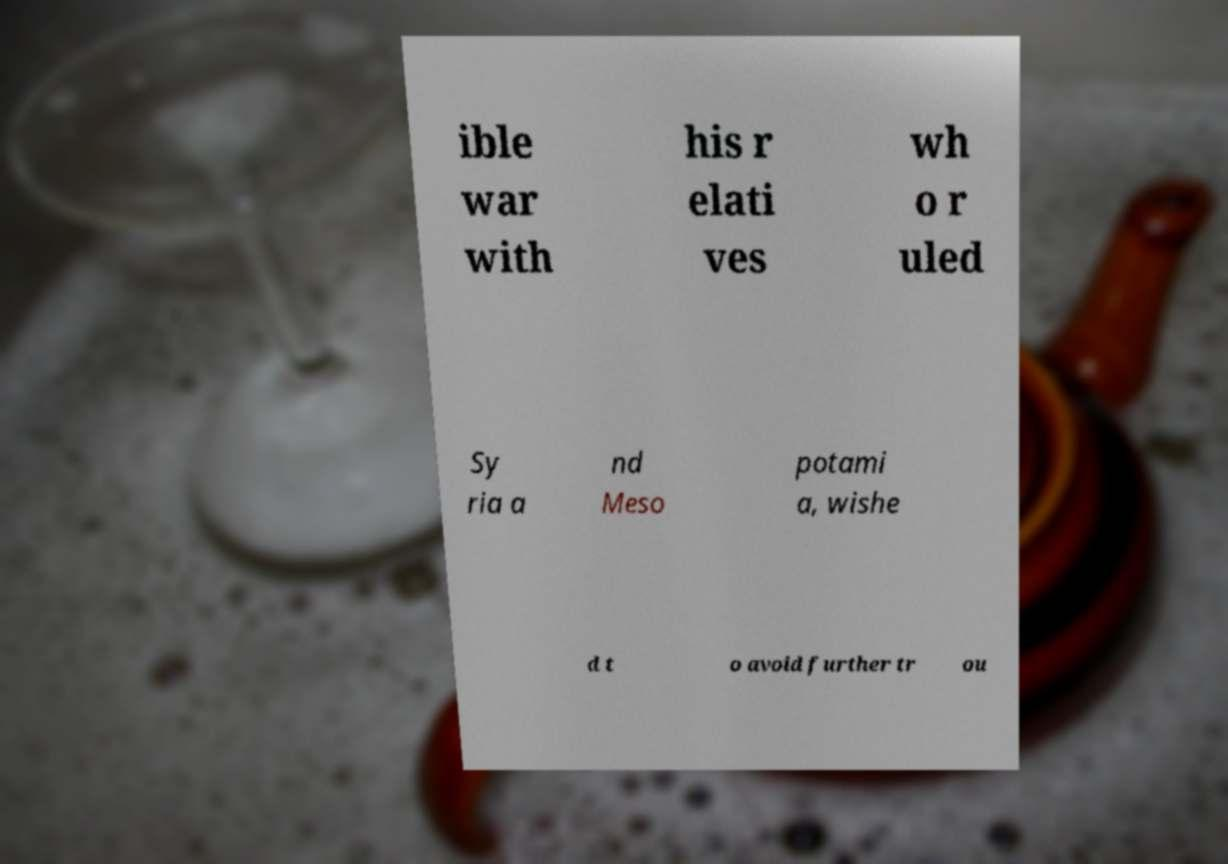Please identify and transcribe the text found in this image. ible war with his r elati ves wh o r uled Sy ria a nd Meso potami a, wishe d t o avoid further tr ou 